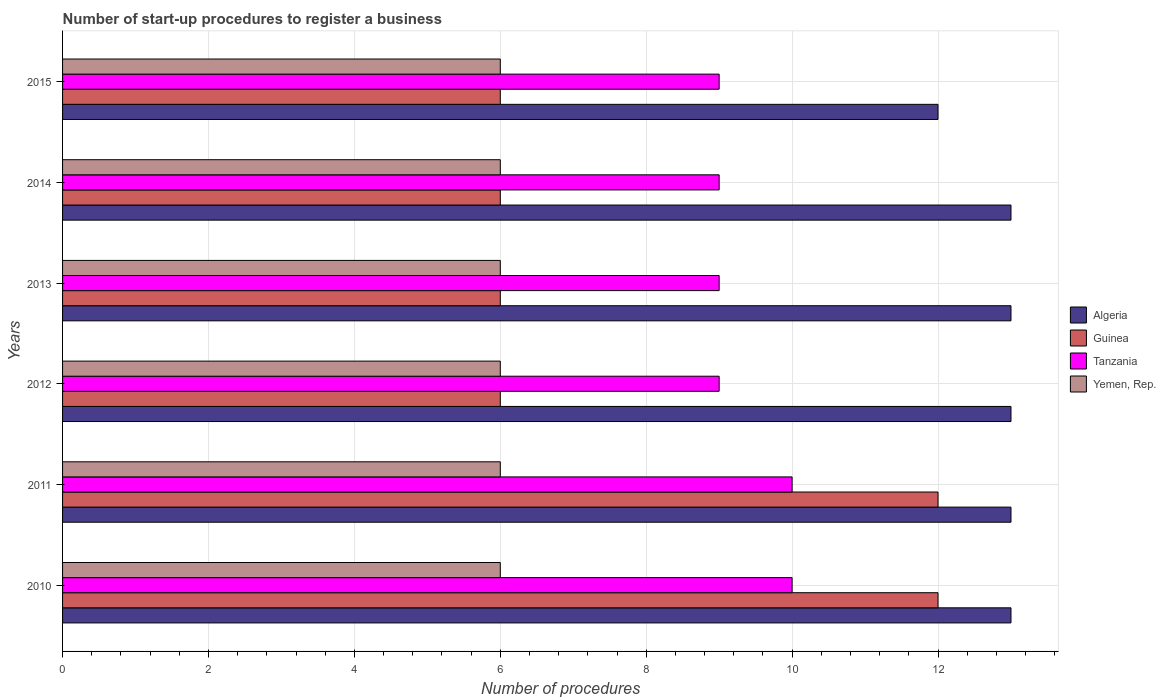How many different coloured bars are there?
Your response must be concise. 4. How many groups of bars are there?
Keep it short and to the point. 6. How many bars are there on the 6th tick from the bottom?
Your answer should be compact. 4. What is the label of the 5th group of bars from the top?
Provide a succinct answer. 2011. In how many cases, is the number of bars for a given year not equal to the number of legend labels?
Your response must be concise. 0. What is the number of procedures required to register a business in Algeria in 2015?
Offer a very short reply. 12. Across all years, what is the maximum number of procedures required to register a business in Algeria?
Offer a terse response. 13. Across all years, what is the minimum number of procedures required to register a business in Algeria?
Your answer should be compact. 12. In which year was the number of procedures required to register a business in Guinea minimum?
Offer a very short reply. 2012. What is the total number of procedures required to register a business in Guinea in the graph?
Offer a terse response. 48. What is the difference between the number of procedures required to register a business in Tanzania in 2011 and that in 2014?
Provide a short and direct response. 1. What is the difference between the number of procedures required to register a business in Algeria in 2010 and the number of procedures required to register a business in Yemen, Rep. in 2012?
Give a very brief answer. 7. What is the average number of procedures required to register a business in Guinea per year?
Your answer should be compact. 8. In the year 2015, what is the difference between the number of procedures required to register a business in Tanzania and number of procedures required to register a business in Algeria?
Give a very brief answer. -3. What is the ratio of the number of procedures required to register a business in Algeria in 2011 to that in 2015?
Provide a short and direct response. 1.08. Is the difference between the number of procedures required to register a business in Tanzania in 2011 and 2014 greater than the difference between the number of procedures required to register a business in Algeria in 2011 and 2014?
Provide a short and direct response. Yes. What is the difference between the highest and the lowest number of procedures required to register a business in Guinea?
Offer a terse response. 6. Is it the case that in every year, the sum of the number of procedures required to register a business in Tanzania and number of procedures required to register a business in Yemen, Rep. is greater than the sum of number of procedures required to register a business in Algeria and number of procedures required to register a business in Guinea?
Offer a terse response. No. What does the 4th bar from the top in 2013 represents?
Your answer should be compact. Algeria. What does the 1st bar from the bottom in 2010 represents?
Give a very brief answer. Algeria. How many bars are there?
Provide a succinct answer. 24. How many years are there in the graph?
Make the answer very short. 6. Does the graph contain any zero values?
Give a very brief answer. No. Does the graph contain grids?
Your answer should be very brief. Yes. How many legend labels are there?
Provide a succinct answer. 4. How are the legend labels stacked?
Make the answer very short. Vertical. What is the title of the graph?
Your response must be concise. Number of start-up procedures to register a business. Does "United Arab Emirates" appear as one of the legend labels in the graph?
Your response must be concise. No. What is the label or title of the X-axis?
Your response must be concise. Number of procedures. What is the Number of procedures in Algeria in 2010?
Your answer should be very brief. 13. What is the Number of procedures in Yemen, Rep. in 2010?
Make the answer very short. 6. What is the Number of procedures of Algeria in 2011?
Your answer should be very brief. 13. What is the Number of procedures of Algeria in 2012?
Your answer should be compact. 13. What is the Number of procedures in Guinea in 2012?
Keep it short and to the point. 6. What is the Number of procedures of Tanzania in 2012?
Ensure brevity in your answer.  9. What is the Number of procedures of Guinea in 2013?
Give a very brief answer. 6. What is the Number of procedures in Algeria in 2014?
Your answer should be compact. 13. What is the Number of procedures of Tanzania in 2014?
Provide a short and direct response. 9. What is the Number of procedures in Algeria in 2015?
Offer a very short reply. 12. What is the Number of procedures of Guinea in 2015?
Offer a terse response. 6. What is the Number of procedures in Tanzania in 2015?
Keep it short and to the point. 9. Across all years, what is the maximum Number of procedures in Guinea?
Offer a terse response. 12. Across all years, what is the maximum Number of procedures of Tanzania?
Ensure brevity in your answer.  10. Across all years, what is the maximum Number of procedures of Yemen, Rep.?
Keep it short and to the point. 6. Across all years, what is the minimum Number of procedures of Algeria?
Your answer should be very brief. 12. Across all years, what is the minimum Number of procedures in Tanzania?
Ensure brevity in your answer.  9. What is the total Number of procedures in Guinea in the graph?
Offer a terse response. 48. What is the total Number of procedures in Tanzania in the graph?
Give a very brief answer. 56. What is the difference between the Number of procedures in Algeria in 2010 and that in 2012?
Keep it short and to the point. 0. What is the difference between the Number of procedures of Algeria in 2010 and that in 2013?
Your response must be concise. 0. What is the difference between the Number of procedures in Guinea in 2010 and that in 2013?
Make the answer very short. 6. What is the difference between the Number of procedures in Tanzania in 2010 and that in 2013?
Provide a succinct answer. 1. What is the difference between the Number of procedures in Algeria in 2010 and that in 2014?
Offer a terse response. 0. What is the difference between the Number of procedures of Guinea in 2010 and that in 2014?
Your answer should be compact. 6. What is the difference between the Number of procedures of Tanzania in 2010 and that in 2015?
Make the answer very short. 1. What is the difference between the Number of procedures in Guinea in 2011 and that in 2012?
Your response must be concise. 6. What is the difference between the Number of procedures in Yemen, Rep. in 2011 and that in 2013?
Your answer should be very brief. 0. What is the difference between the Number of procedures in Algeria in 2011 and that in 2014?
Your answer should be very brief. 0. What is the difference between the Number of procedures in Guinea in 2011 and that in 2014?
Offer a very short reply. 6. What is the difference between the Number of procedures in Tanzania in 2011 and that in 2014?
Make the answer very short. 1. What is the difference between the Number of procedures of Yemen, Rep. in 2011 and that in 2014?
Offer a terse response. 0. What is the difference between the Number of procedures of Guinea in 2011 and that in 2015?
Provide a short and direct response. 6. What is the difference between the Number of procedures in Tanzania in 2011 and that in 2015?
Provide a succinct answer. 1. What is the difference between the Number of procedures in Guinea in 2012 and that in 2013?
Keep it short and to the point. 0. What is the difference between the Number of procedures in Yemen, Rep. in 2012 and that in 2013?
Provide a succinct answer. 0. What is the difference between the Number of procedures of Algeria in 2012 and that in 2014?
Make the answer very short. 0. What is the difference between the Number of procedures of Guinea in 2012 and that in 2014?
Your answer should be very brief. 0. What is the difference between the Number of procedures of Tanzania in 2012 and that in 2014?
Provide a short and direct response. 0. What is the difference between the Number of procedures in Yemen, Rep. in 2012 and that in 2014?
Give a very brief answer. 0. What is the difference between the Number of procedures of Algeria in 2012 and that in 2015?
Keep it short and to the point. 1. What is the difference between the Number of procedures in Tanzania in 2012 and that in 2015?
Ensure brevity in your answer.  0. What is the difference between the Number of procedures of Guinea in 2013 and that in 2014?
Keep it short and to the point. 0. What is the difference between the Number of procedures in Tanzania in 2013 and that in 2014?
Provide a succinct answer. 0. What is the difference between the Number of procedures in Yemen, Rep. in 2013 and that in 2015?
Offer a terse response. 0. What is the difference between the Number of procedures of Guinea in 2014 and that in 2015?
Your answer should be compact. 0. What is the difference between the Number of procedures in Algeria in 2010 and the Number of procedures in Guinea in 2011?
Your answer should be very brief. 1. What is the difference between the Number of procedures in Algeria in 2010 and the Number of procedures in Yemen, Rep. in 2011?
Your answer should be very brief. 7. What is the difference between the Number of procedures in Guinea in 2010 and the Number of procedures in Tanzania in 2011?
Offer a terse response. 2. What is the difference between the Number of procedures of Guinea in 2010 and the Number of procedures of Yemen, Rep. in 2011?
Keep it short and to the point. 6. What is the difference between the Number of procedures in Tanzania in 2010 and the Number of procedures in Yemen, Rep. in 2011?
Give a very brief answer. 4. What is the difference between the Number of procedures of Algeria in 2010 and the Number of procedures of Tanzania in 2012?
Offer a very short reply. 4. What is the difference between the Number of procedures in Guinea in 2010 and the Number of procedures in Yemen, Rep. in 2012?
Your answer should be very brief. 6. What is the difference between the Number of procedures in Algeria in 2010 and the Number of procedures in Guinea in 2013?
Your answer should be very brief. 7. What is the difference between the Number of procedures of Guinea in 2010 and the Number of procedures of Tanzania in 2013?
Offer a terse response. 3. What is the difference between the Number of procedures of Guinea in 2010 and the Number of procedures of Yemen, Rep. in 2013?
Provide a succinct answer. 6. What is the difference between the Number of procedures of Algeria in 2010 and the Number of procedures of Guinea in 2014?
Ensure brevity in your answer.  7. What is the difference between the Number of procedures of Algeria in 2010 and the Number of procedures of Yemen, Rep. in 2014?
Your response must be concise. 7. What is the difference between the Number of procedures in Guinea in 2010 and the Number of procedures in Tanzania in 2014?
Give a very brief answer. 3. What is the difference between the Number of procedures of Guinea in 2010 and the Number of procedures of Yemen, Rep. in 2014?
Provide a succinct answer. 6. What is the difference between the Number of procedures in Algeria in 2010 and the Number of procedures in Yemen, Rep. in 2015?
Keep it short and to the point. 7. What is the difference between the Number of procedures in Guinea in 2010 and the Number of procedures in Yemen, Rep. in 2015?
Keep it short and to the point. 6. What is the difference between the Number of procedures in Algeria in 2011 and the Number of procedures in Guinea in 2012?
Provide a succinct answer. 7. What is the difference between the Number of procedures of Algeria in 2011 and the Number of procedures of Tanzania in 2012?
Make the answer very short. 4. What is the difference between the Number of procedures in Algeria in 2011 and the Number of procedures in Yemen, Rep. in 2012?
Make the answer very short. 7. What is the difference between the Number of procedures in Tanzania in 2011 and the Number of procedures in Yemen, Rep. in 2012?
Offer a very short reply. 4. What is the difference between the Number of procedures of Algeria in 2011 and the Number of procedures of Tanzania in 2013?
Make the answer very short. 4. What is the difference between the Number of procedures of Algeria in 2011 and the Number of procedures of Yemen, Rep. in 2013?
Your response must be concise. 7. What is the difference between the Number of procedures in Guinea in 2011 and the Number of procedures in Tanzania in 2013?
Offer a very short reply. 3. What is the difference between the Number of procedures in Guinea in 2011 and the Number of procedures in Yemen, Rep. in 2013?
Make the answer very short. 6. What is the difference between the Number of procedures of Tanzania in 2011 and the Number of procedures of Yemen, Rep. in 2013?
Give a very brief answer. 4. What is the difference between the Number of procedures of Algeria in 2011 and the Number of procedures of Tanzania in 2014?
Provide a succinct answer. 4. What is the difference between the Number of procedures in Guinea in 2011 and the Number of procedures in Yemen, Rep. in 2014?
Keep it short and to the point. 6. What is the difference between the Number of procedures in Algeria in 2011 and the Number of procedures in Tanzania in 2015?
Offer a terse response. 4. What is the difference between the Number of procedures in Guinea in 2011 and the Number of procedures in Tanzania in 2015?
Provide a short and direct response. 3. What is the difference between the Number of procedures in Tanzania in 2011 and the Number of procedures in Yemen, Rep. in 2015?
Make the answer very short. 4. What is the difference between the Number of procedures in Algeria in 2012 and the Number of procedures in Yemen, Rep. in 2013?
Make the answer very short. 7. What is the difference between the Number of procedures of Algeria in 2012 and the Number of procedures of Guinea in 2014?
Your response must be concise. 7. What is the difference between the Number of procedures in Algeria in 2012 and the Number of procedures in Tanzania in 2014?
Your answer should be very brief. 4. What is the difference between the Number of procedures in Algeria in 2012 and the Number of procedures in Yemen, Rep. in 2014?
Your answer should be very brief. 7. What is the difference between the Number of procedures in Guinea in 2012 and the Number of procedures in Yemen, Rep. in 2014?
Ensure brevity in your answer.  0. What is the difference between the Number of procedures of Algeria in 2012 and the Number of procedures of Guinea in 2015?
Your answer should be very brief. 7. What is the difference between the Number of procedures in Algeria in 2012 and the Number of procedures in Yemen, Rep. in 2015?
Keep it short and to the point. 7. What is the difference between the Number of procedures of Guinea in 2012 and the Number of procedures of Tanzania in 2015?
Your response must be concise. -3. What is the difference between the Number of procedures of Algeria in 2013 and the Number of procedures of Guinea in 2014?
Provide a succinct answer. 7. What is the difference between the Number of procedures in Guinea in 2013 and the Number of procedures in Tanzania in 2014?
Ensure brevity in your answer.  -3. What is the difference between the Number of procedures in Guinea in 2013 and the Number of procedures in Yemen, Rep. in 2014?
Give a very brief answer. 0. What is the difference between the Number of procedures of Algeria in 2013 and the Number of procedures of Guinea in 2015?
Give a very brief answer. 7. What is the difference between the Number of procedures in Algeria in 2013 and the Number of procedures in Tanzania in 2015?
Give a very brief answer. 4. What is the difference between the Number of procedures of Guinea in 2013 and the Number of procedures of Tanzania in 2015?
Your answer should be very brief. -3. What is the difference between the Number of procedures of Guinea in 2013 and the Number of procedures of Yemen, Rep. in 2015?
Keep it short and to the point. 0. What is the difference between the Number of procedures of Algeria in 2014 and the Number of procedures of Guinea in 2015?
Your answer should be compact. 7. What is the difference between the Number of procedures in Algeria in 2014 and the Number of procedures in Tanzania in 2015?
Your response must be concise. 4. What is the difference between the Number of procedures in Tanzania in 2014 and the Number of procedures in Yemen, Rep. in 2015?
Ensure brevity in your answer.  3. What is the average Number of procedures of Algeria per year?
Your answer should be compact. 12.83. What is the average Number of procedures of Tanzania per year?
Keep it short and to the point. 9.33. In the year 2010, what is the difference between the Number of procedures in Guinea and Number of procedures in Tanzania?
Your response must be concise. 2. In the year 2010, what is the difference between the Number of procedures of Guinea and Number of procedures of Yemen, Rep.?
Provide a succinct answer. 6. In the year 2010, what is the difference between the Number of procedures in Tanzania and Number of procedures in Yemen, Rep.?
Make the answer very short. 4. In the year 2011, what is the difference between the Number of procedures of Guinea and Number of procedures of Tanzania?
Your answer should be compact. 2. In the year 2011, what is the difference between the Number of procedures in Guinea and Number of procedures in Yemen, Rep.?
Your answer should be compact. 6. In the year 2012, what is the difference between the Number of procedures of Algeria and Number of procedures of Guinea?
Your answer should be very brief. 7. In the year 2012, what is the difference between the Number of procedures of Algeria and Number of procedures of Tanzania?
Offer a very short reply. 4. In the year 2012, what is the difference between the Number of procedures in Algeria and Number of procedures in Yemen, Rep.?
Provide a succinct answer. 7. In the year 2012, what is the difference between the Number of procedures in Guinea and Number of procedures in Tanzania?
Give a very brief answer. -3. In the year 2013, what is the difference between the Number of procedures in Algeria and Number of procedures in Guinea?
Ensure brevity in your answer.  7. In the year 2013, what is the difference between the Number of procedures of Algeria and Number of procedures of Yemen, Rep.?
Keep it short and to the point. 7. In the year 2015, what is the difference between the Number of procedures of Algeria and Number of procedures of Guinea?
Offer a very short reply. 6. In the year 2015, what is the difference between the Number of procedures in Algeria and Number of procedures in Tanzania?
Provide a short and direct response. 3. In the year 2015, what is the difference between the Number of procedures in Algeria and Number of procedures in Yemen, Rep.?
Your answer should be very brief. 6. In the year 2015, what is the difference between the Number of procedures in Guinea and Number of procedures in Tanzania?
Ensure brevity in your answer.  -3. In the year 2015, what is the difference between the Number of procedures in Guinea and Number of procedures in Yemen, Rep.?
Your answer should be compact. 0. In the year 2015, what is the difference between the Number of procedures of Tanzania and Number of procedures of Yemen, Rep.?
Make the answer very short. 3. What is the ratio of the Number of procedures of Algeria in 2010 to that in 2011?
Provide a succinct answer. 1. What is the ratio of the Number of procedures of Guinea in 2010 to that in 2011?
Keep it short and to the point. 1. What is the ratio of the Number of procedures of Yemen, Rep. in 2010 to that in 2011?
Your response must be concise. 1. What is the ratio of the Number of procedures of Tanzania in 2010 to that in 2012?
Keep it short and to the point. 1.11. What is the ratio of the Number of procedures of Yemen, Rep. in 2010 to that in 2012?
Your response must be concise. 1. What is the ratio of the Number of procedures of Algeria in 2010 to that in 2013?
Make the answer very short. 1. What is the ratio of the Number of procedures in Guinea in 2010 to that in 2013?
Provide a succinct answer. 2. What is the ratio of the Number of procedures in Algeria in 2010 to that in 2014?
Make the answer very short. 1. What is the ratio of the Number of procedures of Tanzania in 2010 to that in 2014?
Ensure brevity in your answer.  1.11. What is the ratio of the Number of procedures in Yemen, Rep. in 2010 to that in 2014?
Keep it short and to the point. 1. What is the ratio of the Number of procedures in Guinea in 2010 to that in 2015?
Make the answer very short. 2. What is the ratio of the Number of procedures in Tanzania in 2010 to that in 2015?
Offer a terse response. 1.11. What is the ratio of the Number of procedures in Yemen, Rep. in 2010 to that in 2015?
Your answer should be very brief. 1. What is the ratio of the Number of procedures in Guinea in 2011 to that in 2012?
Give a very brief answer. 2. What is the ratio of the Number of procedures in Algeria in 2011 to that in 2014?
Provide a succinct answer. 1. What is the ratio of the Number of procedures of Tanzania in 2011 to that in 2014?
Provide a succinct answer. 1.11. What is the ratio of the Number of procedures in Algeria in 2011 to that in 2015?
Offer a terse response. 1.08. What is the ratio of the Number of procedures in Guinea in 2011 to that in 2015?
Your response must be concise. 2. What is the ratio of the Number of procedures in Tanzania in 2011 to that in 2015?
Your response must be concise. 1.11. What is the ratio of the Number of procedures in Yemen, Rep. in 2011 to that in 2015?
Ensure brevity in your answer.  1. What is the ratio of the Number of procedures in Guinea in 2012 to that in 2013?
Ensure brevity in your answer.  1. What is the ratio of the Number of procedures in Yemen, Rep. in 2012 to that in 2013?
Keep it short and to the point. 1. What is the ratio of the Number of procedures in Algeria in 2012 to that in 2014?
Ensure brevity in your answer.  1. What is the ratio of the Number of procedures in Guinea in 2012 to that in 2014?
Your answer should be compact. 1. What is the ratio of the Number of procedures of Tanzania in 2012 to that in 2014?
Ensure brevity in your answer.  1. What is the ratio of the Number of procedures in Yemen, Rep. in 2012 to that in 2015?
Offer a very short reply. 1. What is the ratio of the Number of procedures in Tanzania in 2013 to that in 2014?
Provide a short and direct response. 1. What is the ratio of the Number of procedures of Algeria in 2013 to that in 2015?
Your answer should be compact. 1.08. What is the ratio of the Number of procedures of Guinea in 2013 to that in 2015?
Make the answer very short. 1. What is the ratio of the Number of procedures of Tanzania in 2013 to that in 2015?
Ensure brevity in your answer.  1. What is the ratio of the Number of procedures of Guinea in 2014 to that in 2015?
Make the answer very short. 1. What is the ratio of the Number of procedures in Tanzania in 2014 to that in 2015?
Keep it short and to the point. 1. What is the ratio of the Number of procedures of Yemen, Rep. in 2014 to that in 2015?
Your response must be concise. 1. What is the difference between the highest and the second highest Number of procedures in Algeria?
Your answer should be very brief. 0. What is the difference between the highest and the second highest Number of procedures in Yemen, Rep.?
Offer a very short reply. 0. What is the difference between the highest and the lowest Number of procedures of Guinea?
Offer a very short reply. 6. 